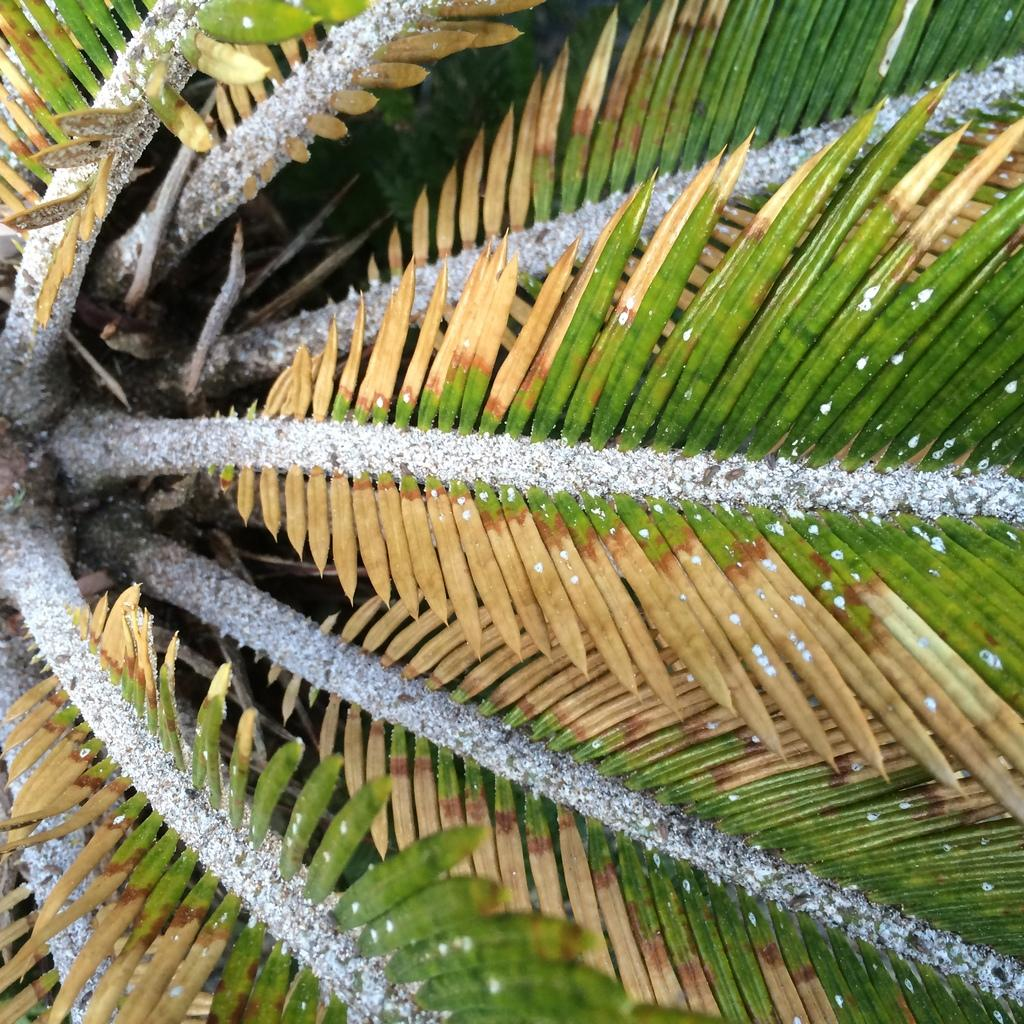What type of plant can be seen in the image? There is a tree with leaves in the image. What is the color of the objects in the tree? The objects in the tree are white. What time of day is it in the image, and how does the tree stretch during that time? The time of day is not mentioned in the image, and trees do not stretch like living beings. 